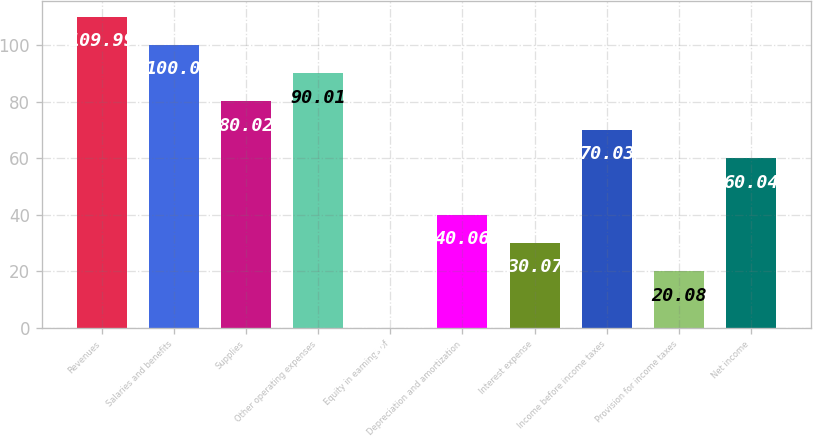Convert chart. <chart><loc_0><loc_0><loc_500><loc_500><bar_chart><fcel>Revenues<fcel>Salaries and benefits<fcel>Supplies<fcel>Other operating expenses<fcel>Equity in earnings of<fcel>Depreciation and amortization<fcel>Interest expense<fcel>Income before income taxes<fcel>Provision for income taxes<fcel>Net income<nl><fcel>109.99<fcel>100<fcel>80.02<fcel>90.01<fcel>0.1<fcel>40.06<fcel>30.07<fcel>70.03<fcel>20.08<fcel>60.04<nl></chart> 